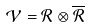Convert formula to latex. <formula><loc_0><loc_0><loc_500><loc_500>\mathcal { V } = \mathcal { R } \otimes \overline { \mathcal { R } }</formula> 